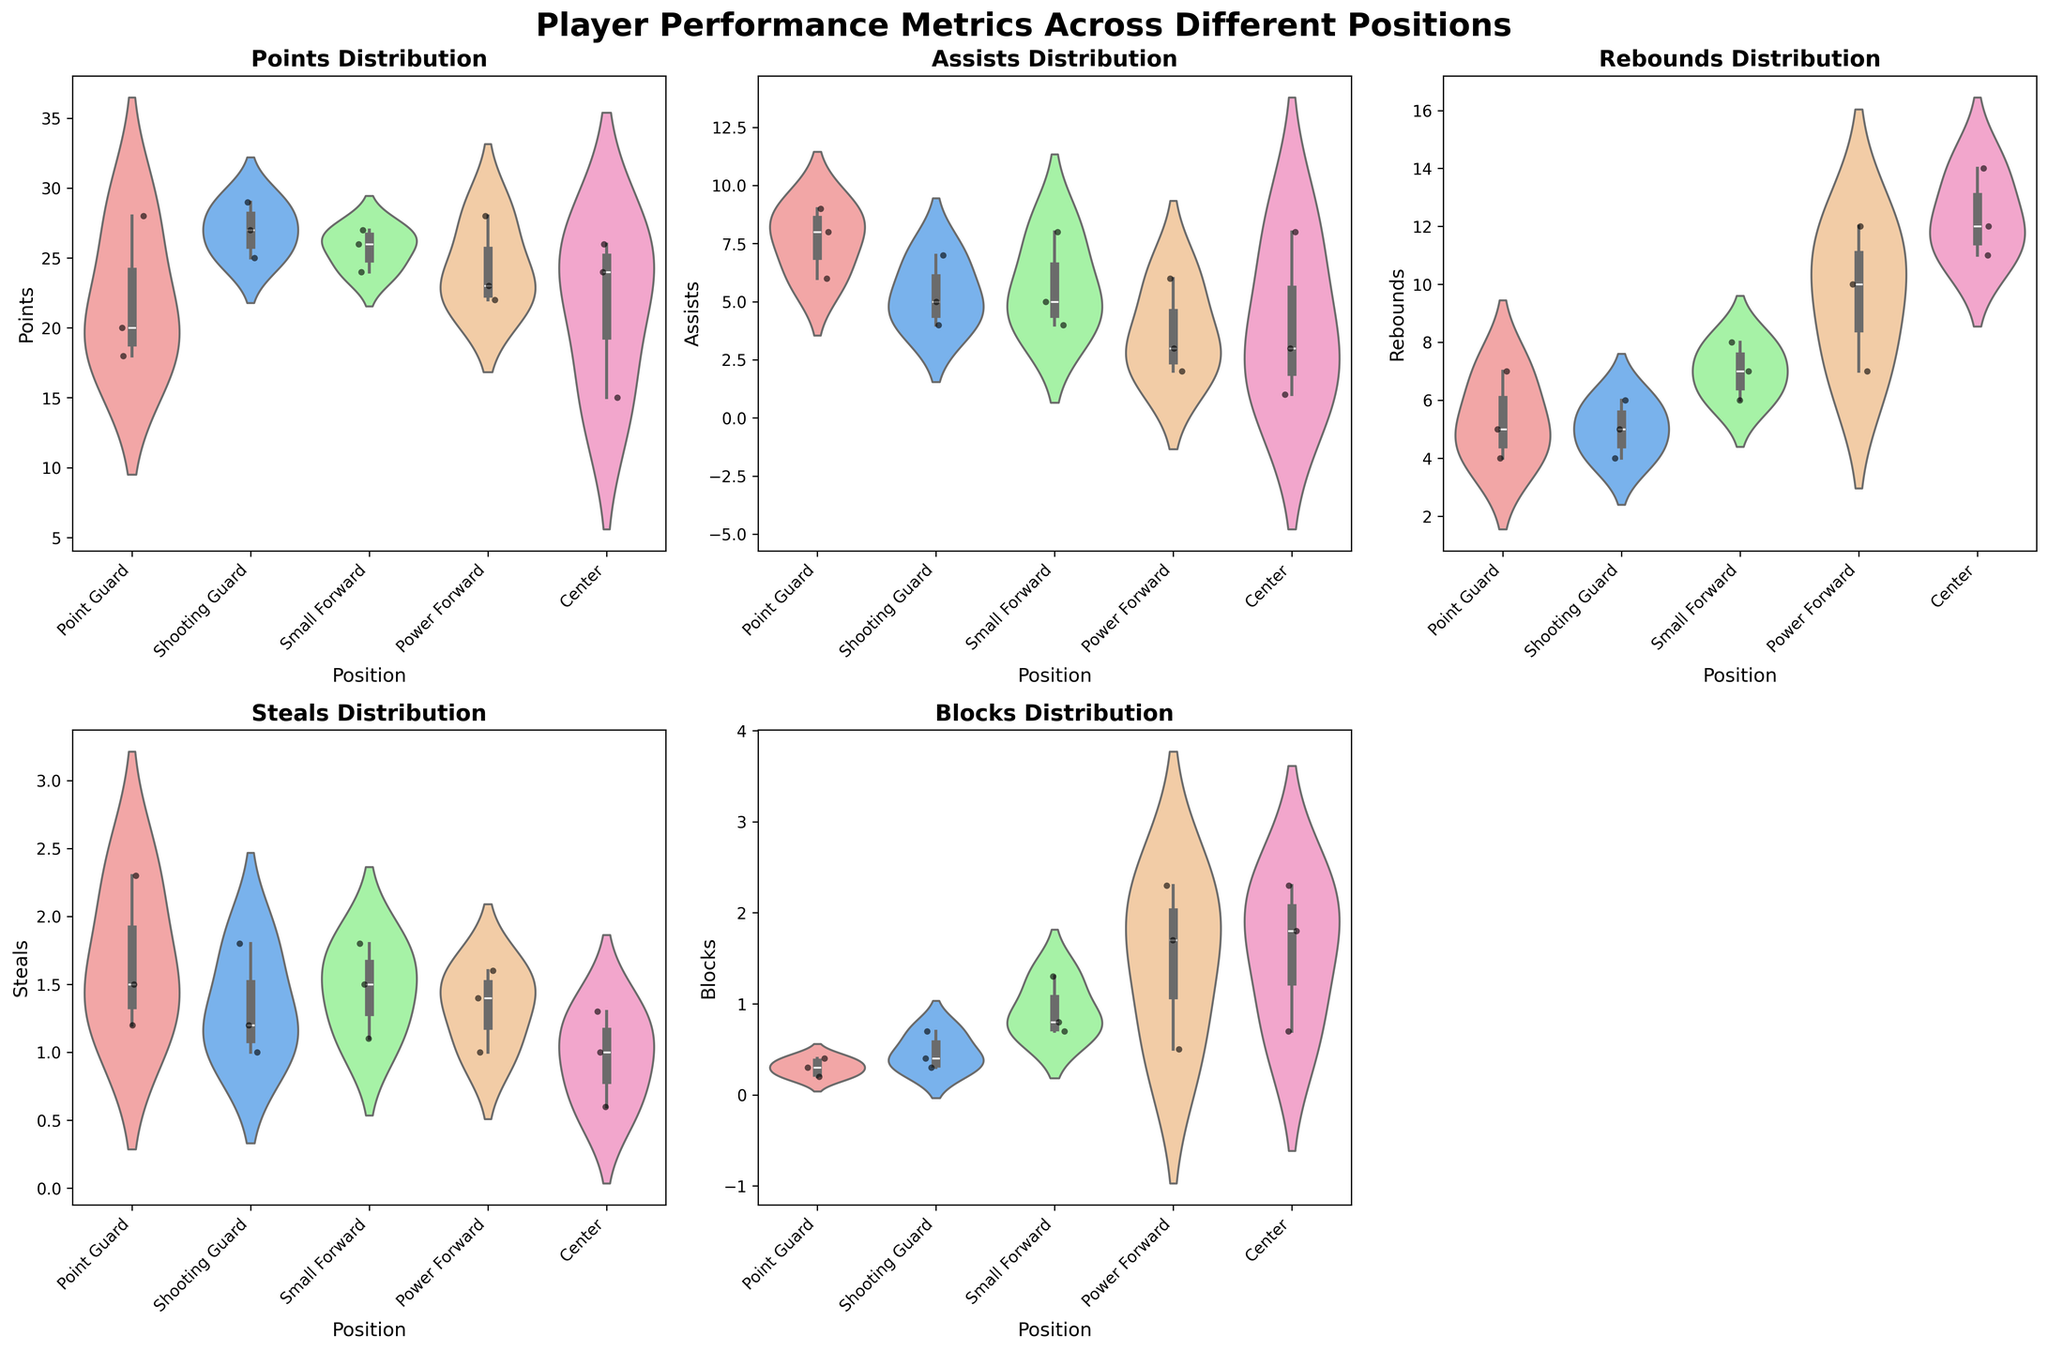Which position has the widest range of Points? The widest range in the violin plot for Points can be identified by observing the spread from the thin tail to the thick body of the plot. This visualization indicates how much variability there is in the data for each position.
Answer: Point Guard Are there any positions where Assists have a noticeably larger interquartile range than others? The interquartile range (IQR) can be inferred by looking at the thickest part of the violin plot for Assists. If one position has a noticeably larger thick body compared to others, then it has a larger IQR. Point Guard and Center positions have larger IQRs for Assists.
Answer: Yes, Point Guard and Center Which position tends to have the highest median Rebounds? The median is typically represented by the thicker central part along the y-axis through the middle of each violin plot. By comparing the centerline positions of the Rebounds, we observe higher medians for certain positions.
Answer: Center Do Guards generally have higher or lower Steals compared to Forwards and Centers? To compare this, we look at the violin plots for Steals and observe the overall distribution. On average, the Steals distribution for Guards (Point Guard, Shooting Guard) appears generally higher than that for Forwards and Centers.
Answer: Higher Which position has the least variability in Blocks? Variability can be assessed by the width of the violin plot for Blocks. The narrower the plot, the less variability there is in the data for that position.
Answer: Shooting Guard Which position has the highest peak (density) in the distribution of Points? The highest peak can be identified by observing the tallness of the thickest part of the violin plot. The taller the thickest part, the greater the density of points at that value. Shooting Guard and Point Guard have high densities.
Answer: Shooting Guard and Point Guard Is there a position that consistently shows outliers across multiple metrics? Outliers are shown as points outside the main body of a violin plot. By examining all the plots, we can identify if any position has a greater number of scattered points beyond the main distribution band.
Answer: Point Guard Which position shows the least spread in Assists distribution? The least spread is indicated by the narrowest part of the plot for Assists. Less spread means the majority of the data is concentrated around the median with fewer extreme values.
Answer: Power Forward How does the Rebounds distribution of Centers compare to Power Forwards? By comparing the violin plots for Rebounds of Centers and Power Forwards, we assess the differences in distribution shape and central tendency. Centers generally have higher Rebounds with a similar or slightly broader distribution than Power Forwards.
Answer: Centers have higher and slightly broader Rebounds distribution Do Point Guards generally have more or fewer Assists than Small Forwards? Comparing the central tendency and density of the Assists violin plots for Point Guards and Small Forwards, Point Guards appear to generally have more Assists.
Answer: More 